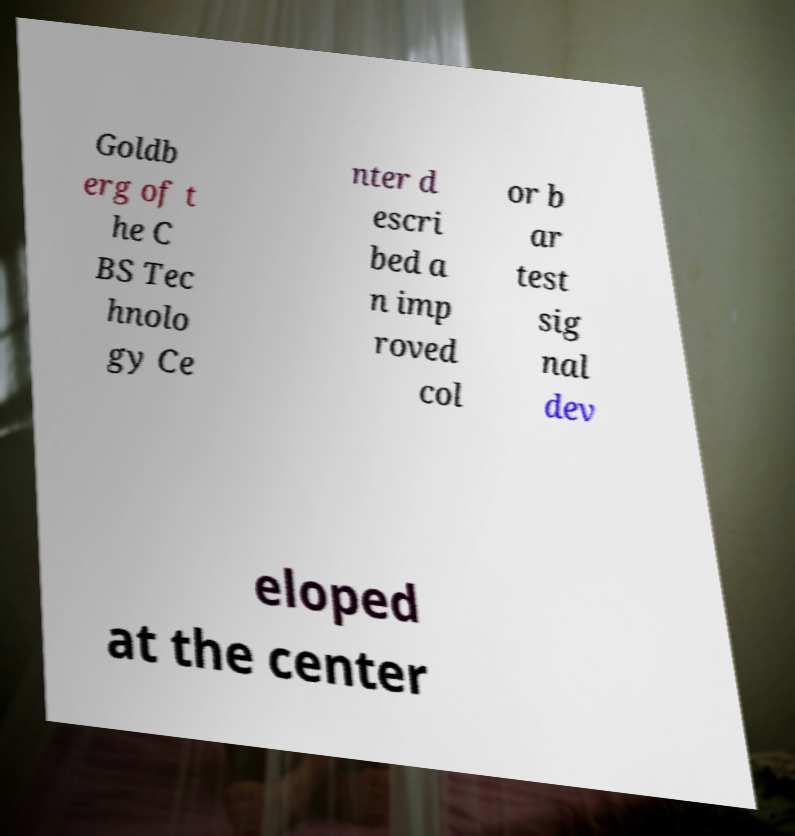Please identify and transcribe the text found in this image. Goldb erg of t he C BS Tec hnolo gy Ce nter d escri bed a n imp roved col or b ar test sig nal dev eloped at the center 